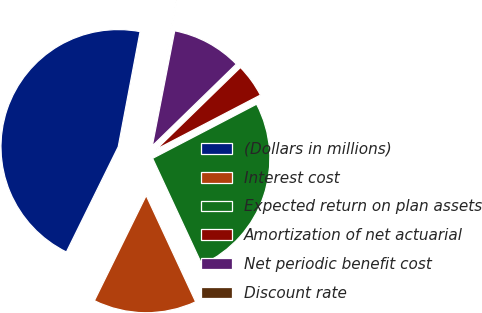Convert chart. <chart><loc_0><loc_0><loc_500><loc_500><pie_chart><fcel>(Dollars in millions)<fcel>Interest cost<fcel>Expected return on plan assets<fcel>Amortization of net actuarial<fcel>Net periodic benefit cost<fcel>Discount rate<nl><fcel>45.7%<fcel>14.21%<fcel>25.72%<fcel>4.64%<fcel>9.65%<fcel>0.08%<nl></chart> 